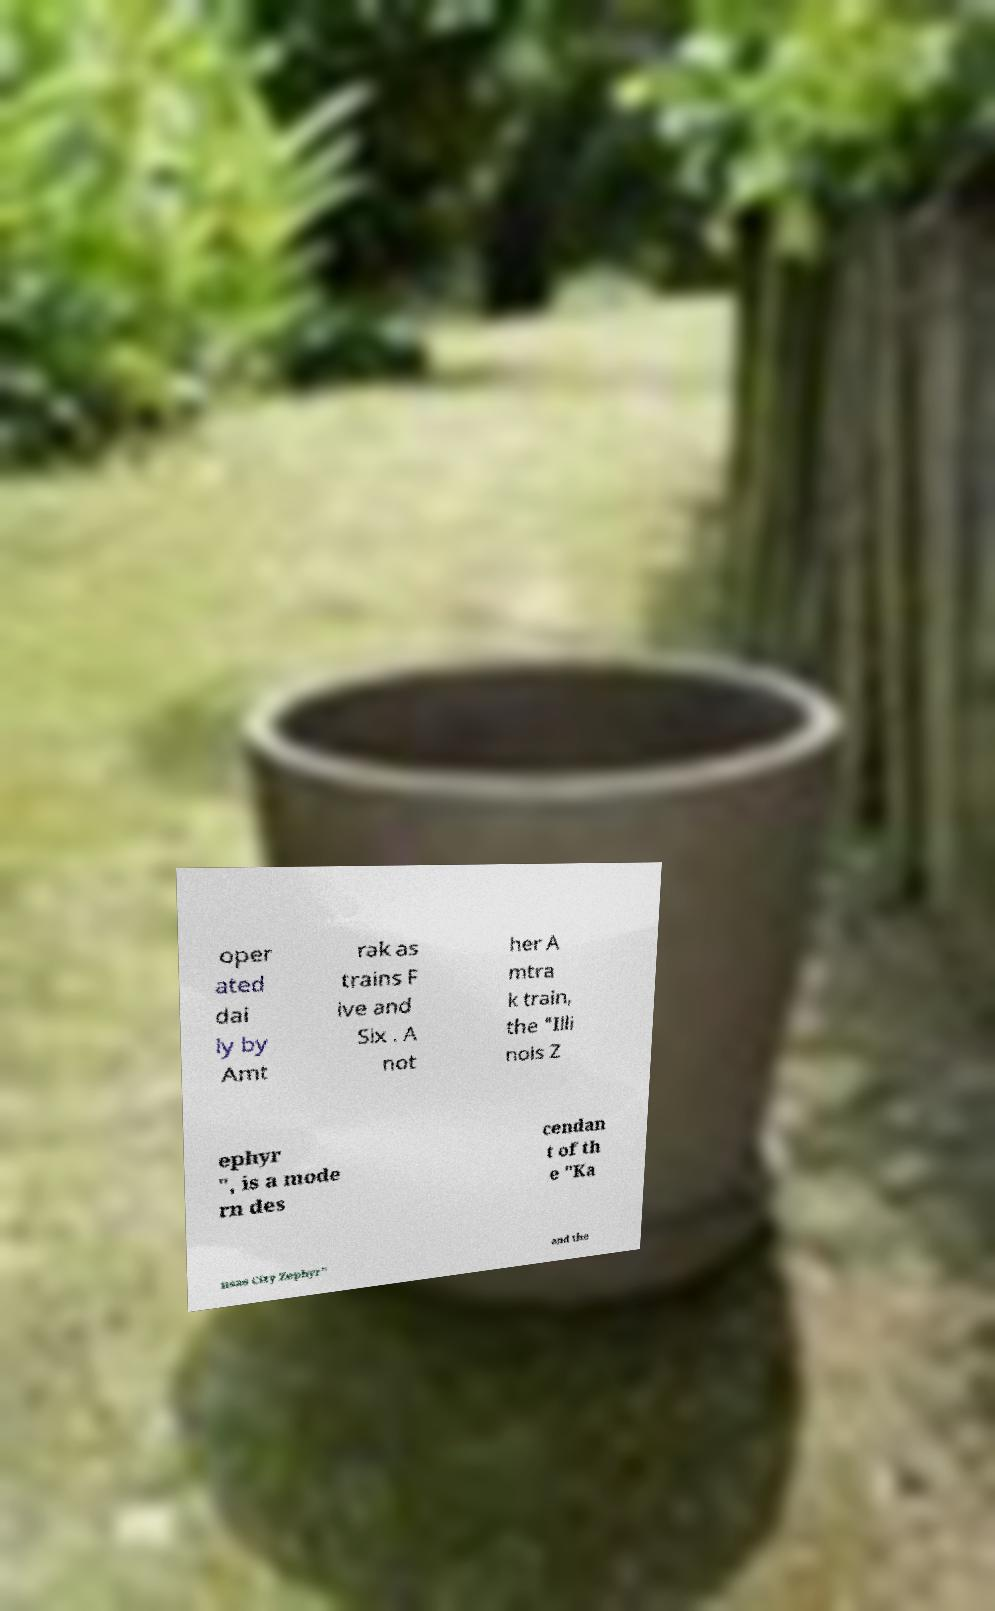Please identify and transcribe the text found in this image. oper ated dai ly by Amt rak as trains F ive and Six . A not her A mtra k train, the "Illi nois Z ephyr ", is a mode rn des cendan t of th e "Ka nsas City Zephyr" and the 